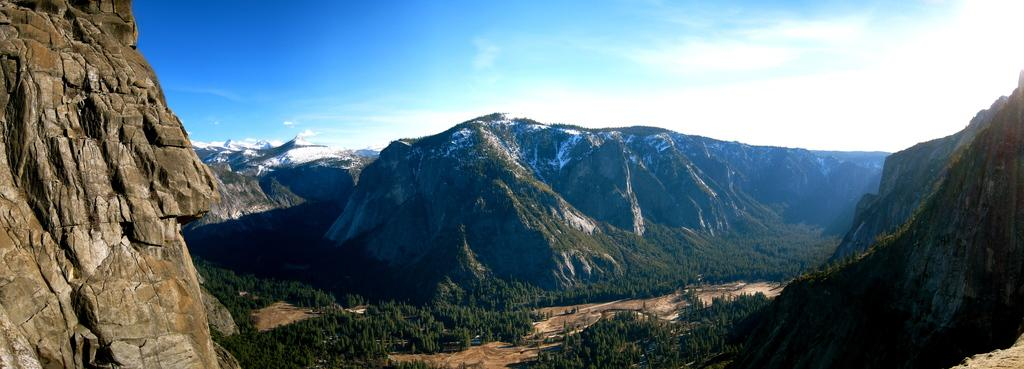What type of natural features can be seen in the image? There are trees, hills, and mountains in the image. What is visible in the background of the image? The sky is visible in the image. What can be observed in the sky? Clouds are present in the sky. What is the reaction of the gate to the clouds in the image? There is no gate present in the image, so it cannot have a reaction to the clouds. 